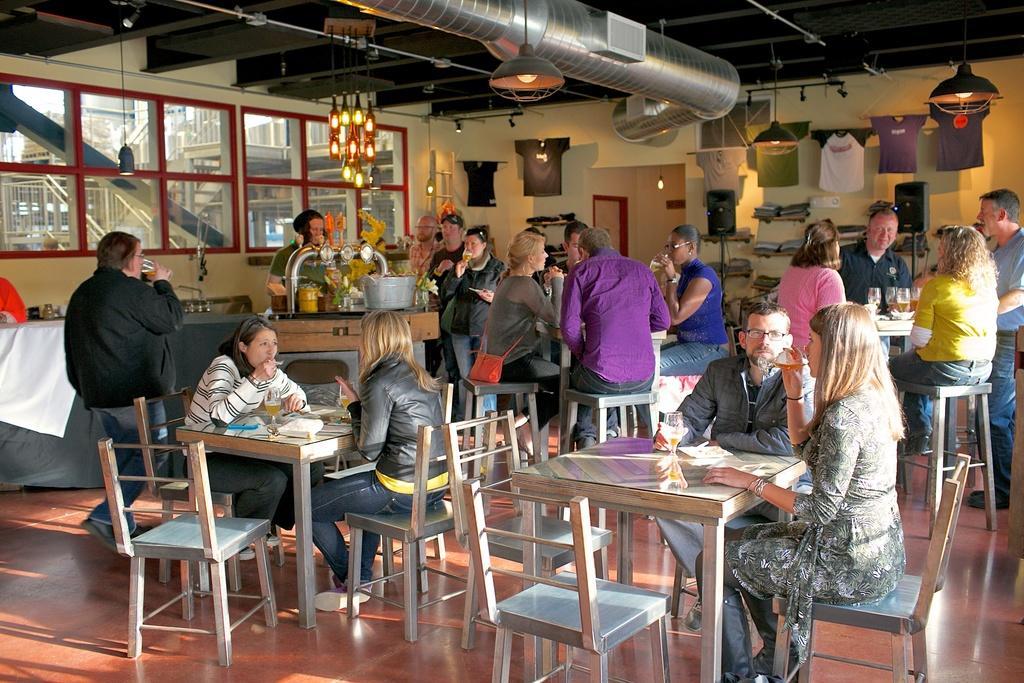Describe this image in one or two sentences. In this image we can see a group of people are sitting on the chair, and in front here is the table and glass and some objects on it, and here are the group of people standing, and here is the light, and here is the wall. 